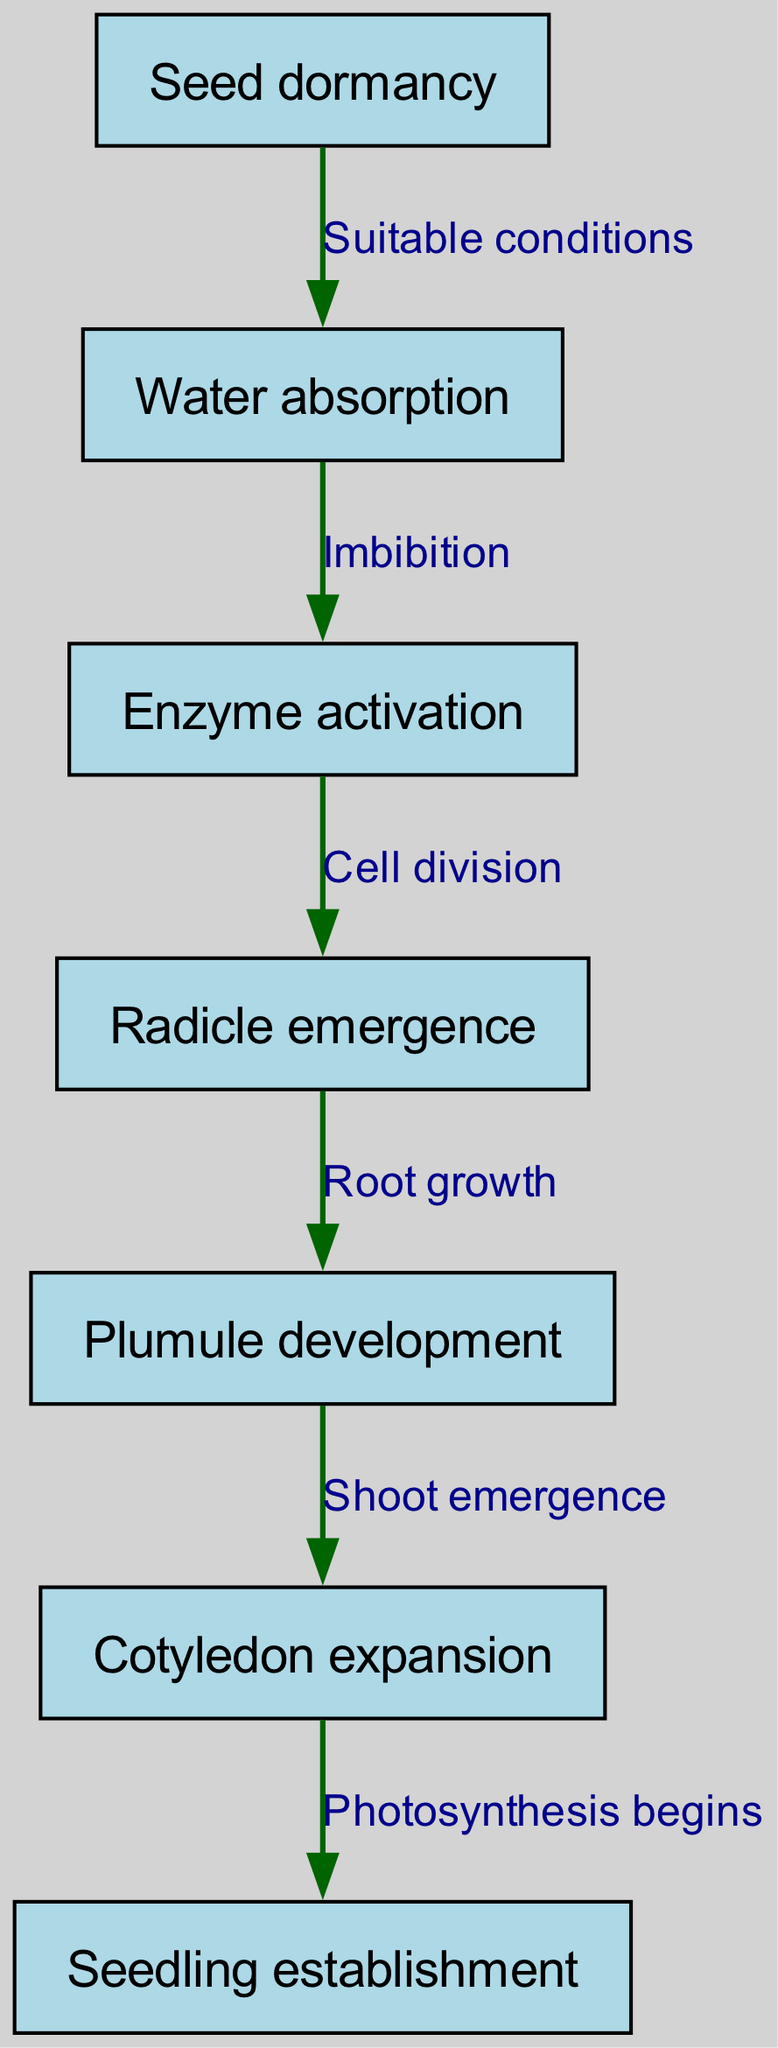What is the first stage of seed germination in the diagram? The first stage of seed germination according to the diagram is "Seed dormancy," which is mentioned as the starting node.
Answer: Seed dormancy How many edges are there in the flow chart? By counting each connection or edge in the diagram, we find there are a total of six edges showing the relationships between the nodes.
Answer: 6 What follows "Water absorption" in the seed germination process? The node that follows "Water absorption" is "Enzyme activation," which is directly connected through an edge describing the relationship of "Imbibition."
Answer: Enzyme activation What is the relationship between "Plumule development" and "Cotyledon expansion"? The relationship is that "Plumule development" leads to "Cotyledon expansion," indicated by a connecting edge labeled "Shoot emergence."
Answer: Shoot emergence What stage occurs after "Radicle emergence"? After "Radicle emergence," the next stage represented in the diagram is "Plumule development," which is the following connected node.
Answer: Plumule development What is the last stage of seed germination mentioned? The last stage, or end node, of seed germination in the diagram is "Seedling establishment," showing the final outcome of the germination process.
Answer: Seedling establishment Which node connects "Enzyme activation" to "Radicle emergence"? The node that connects "Enzyme activation" to "Radicle emergence" is represented by the edge, with the description indicating "Cell division" as the process leading to the next stage.
Answer: Cell division How does "Cotyledon expansion" relate to the beginning of photosynthesis? "Cotyledon expansion" is the stage just before "Seedling establishment," and it establishes that "Photosynthesis begins" is initiated as seedling grows and expands its leaves.
Answer: Photosynthesis begins 